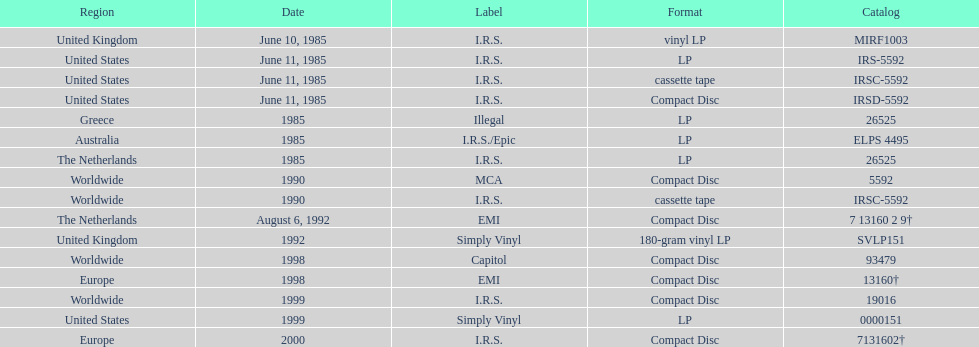Which zone has over one format? United States. 